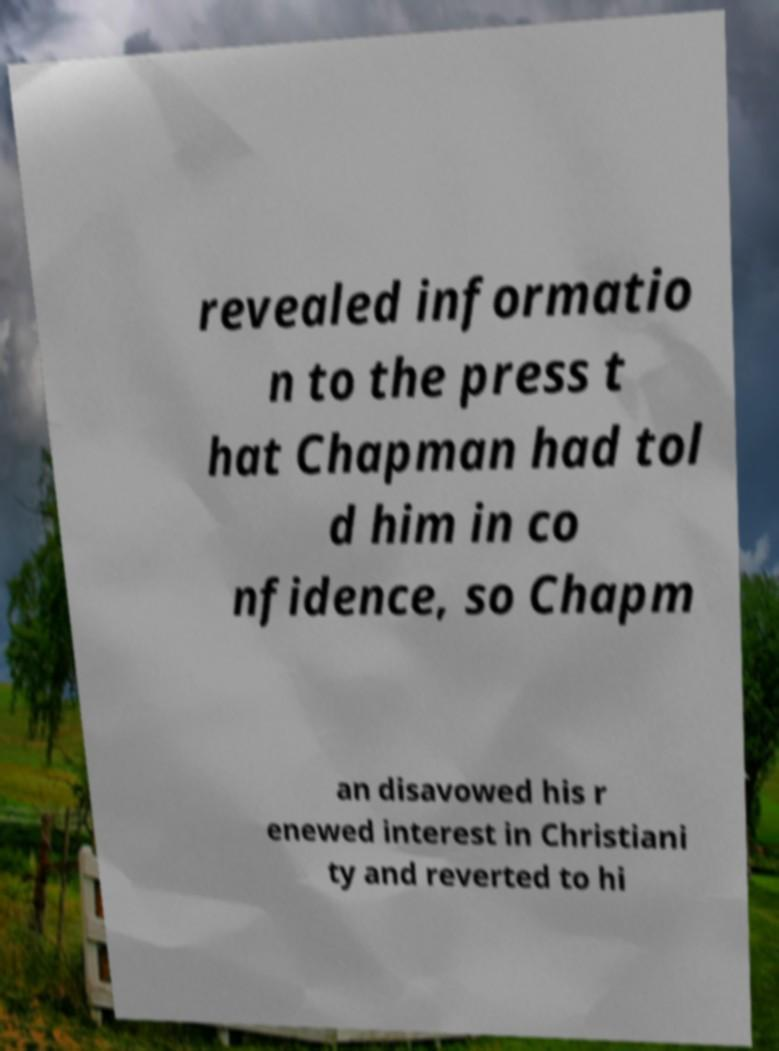Could you extract and type out the text from this image? revealed informatio n to the press t hat Chapman had tol d him in co nfidence, so Chapm an disavowed his r enewed interest in Christiani ty and reverted to hi 